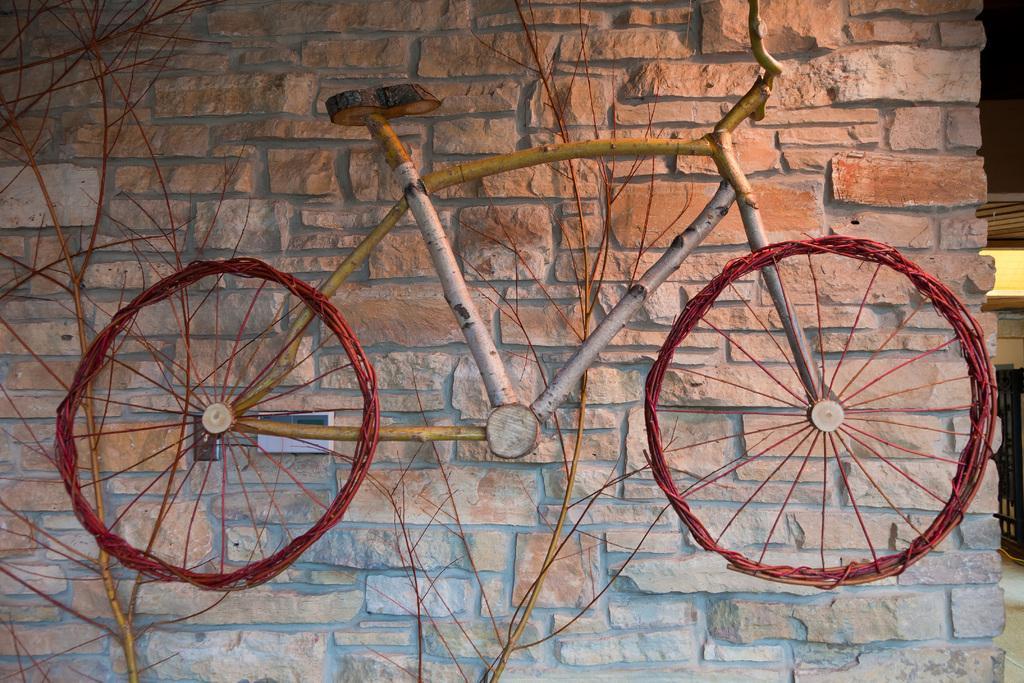What is the main subject of the image? There is a depiction of a bicycle in the image. What else can be seen in the image besides the bicycle? There are stems visible in the image. What is in the background of the image? There is a wall in the background of the image. What advice does the uncle give about the bicycle in the image? There is no uncle present in the image, and therefore no advice can be attributed to him. 